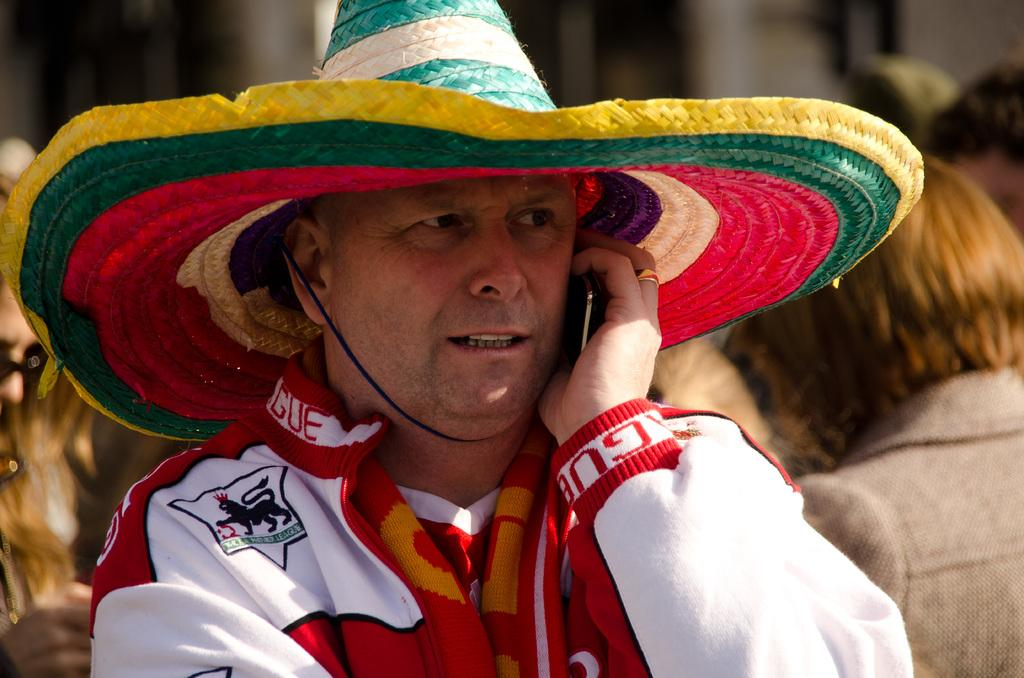What can be seen in the image? There is a person in the image. What is the person wearing? The person is wearing a hat. What is the person holding? The person is holding a mobile. Can you describe the background of the image? There is a group of people in the background of the image, and the background is blurry. What type of cloth is being used to make the person's hat in the image? There is no information about the type of cloth used to make the person's hat in the image. How many pets are visible in the image? There are no pets visible in the image. 